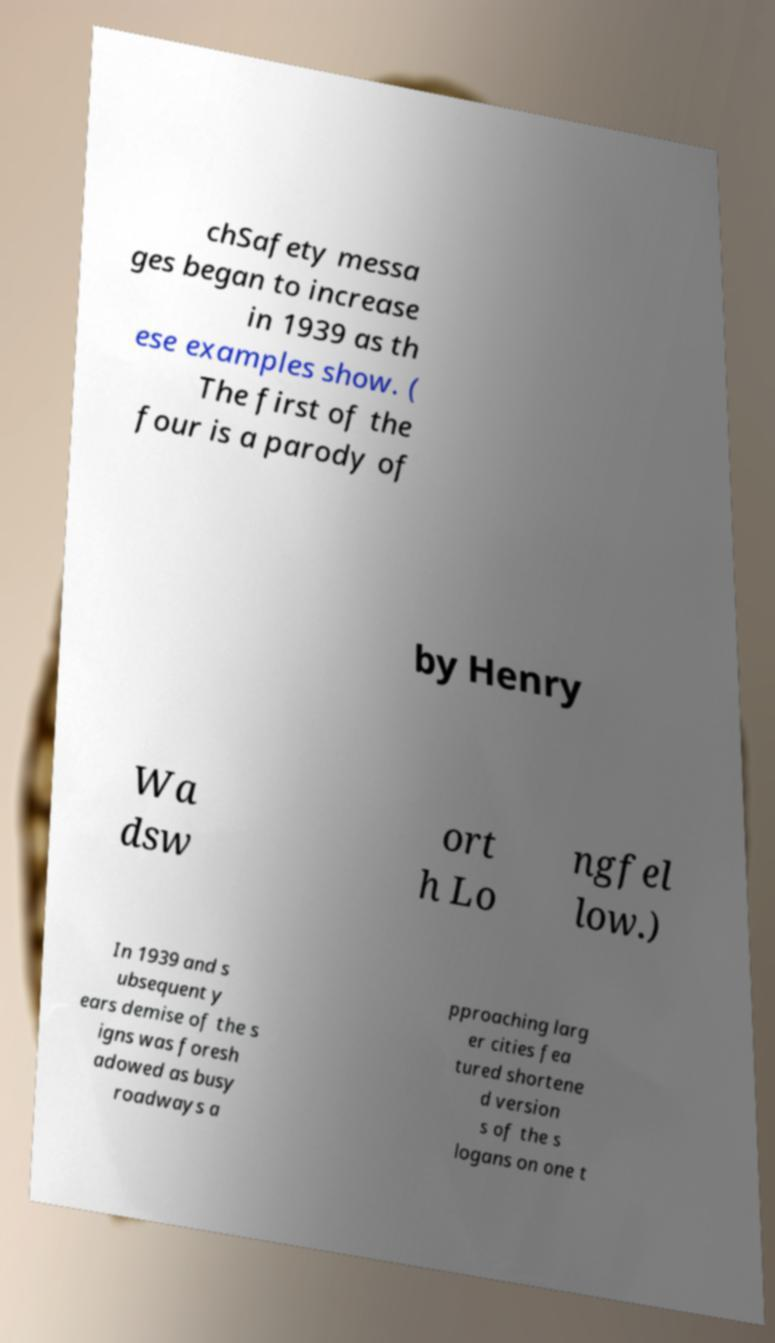What messages or text are displayed in this image? I need them in a readable, typed format. chSafety messa ges began to increase in 1939 as th ese examples show. ( The first of the four is a parody of by Henry Wa dsw ort h Lo ngfel low.) In 1939 and s ubsequent y ears demise of the s igns was foresh adowed as busy roadways a pproaching larg er cities fea tured shortene d version s of the s logans on one t 